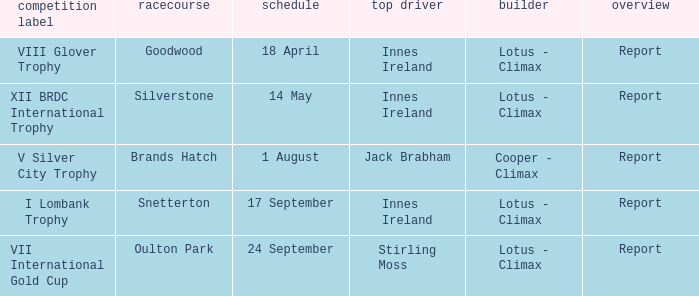What is the name of the race where Stirling Moss was the winning driver? VII International Gold Cup. 